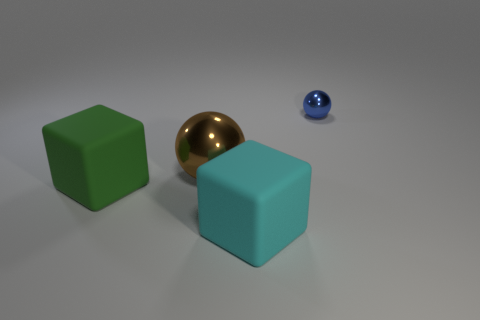What size is the blue thing?
Offer a terse response. Small. What number of cyan matte objects have the same size as the brown shiny object?
Give a very brief answer. 1. Are the block right of the green object and the large green cube to the left of the tiny blue ball made of the same material?
Offer a very short reply. Yes. Is the number of cyan rubber cubes greater than the number of large brown rubber balls?
Provide a succinct answer. Yes. Is there anything else that is the same color as the tiny object?
Keep it short and to the point. No. Do the blue ball and the cyan block have the same material?
Give a very brief answer. No. Is the number of small blue spheres less than the number of metallic balls?
Offer a very short reply. Yes. Does the large brown thing have the same shape as the green object?
Keep it short and to the point. No. What color is the big metallic sphere?
Keep it short and to the point. Brown. How many other objects are the same material as the tiny sphere?
Provide a succinct answer. 1. 